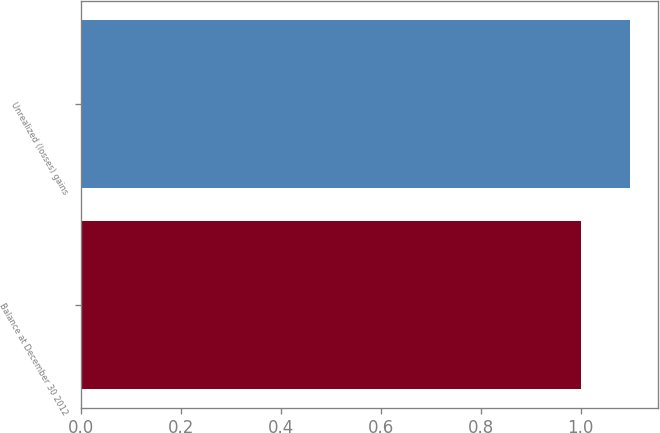Convert chart. <chart><loc_0><loc_0><loc_500><loc_500><bar_chart><fcel>Balance at December 30 2012<fcel>Unrealized (losses) gains<nl><fcel>1<fcel>1.1<nl></chart> 